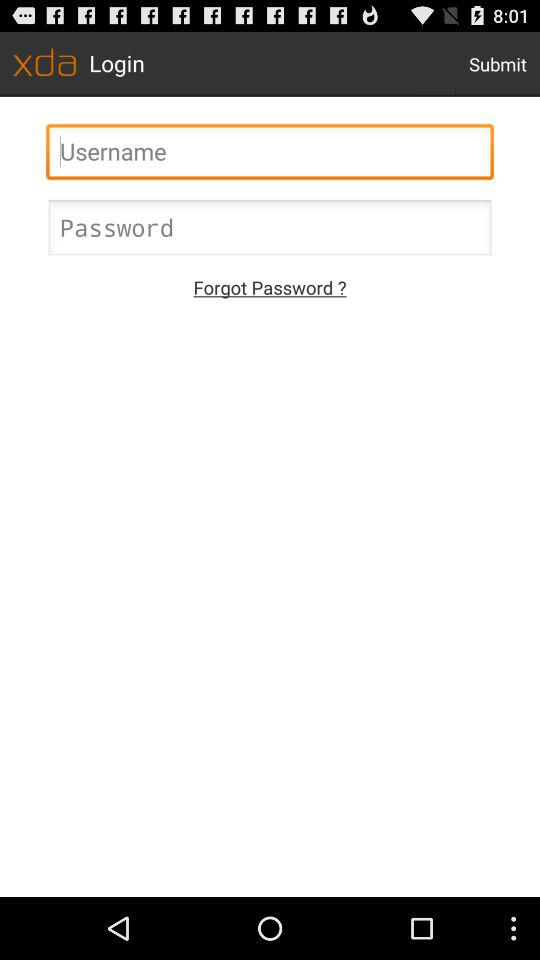What is the name of the application? The name of the application is "xda". 